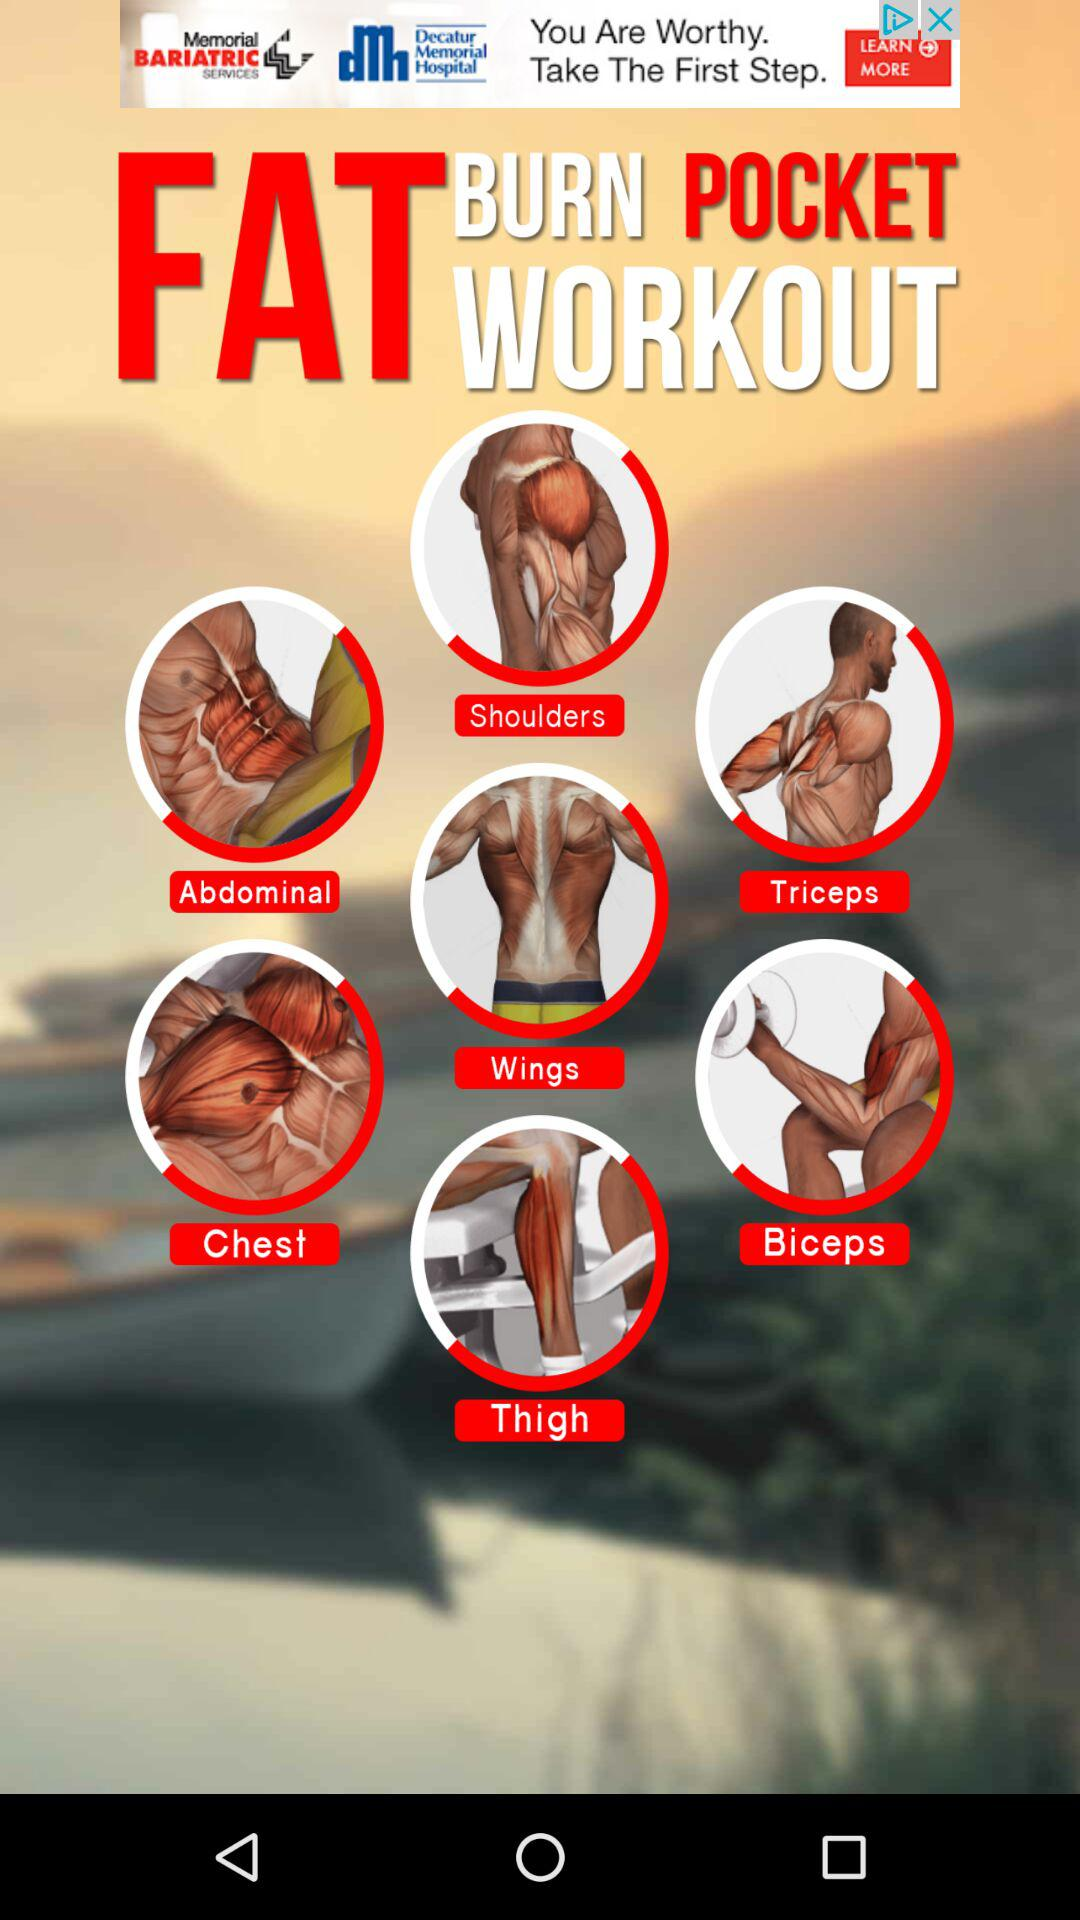How many people are using the "FAT BURN POCKET WORKOUT" application?
When the provided information is insufficient, respond with <no answer>. <no answer> 